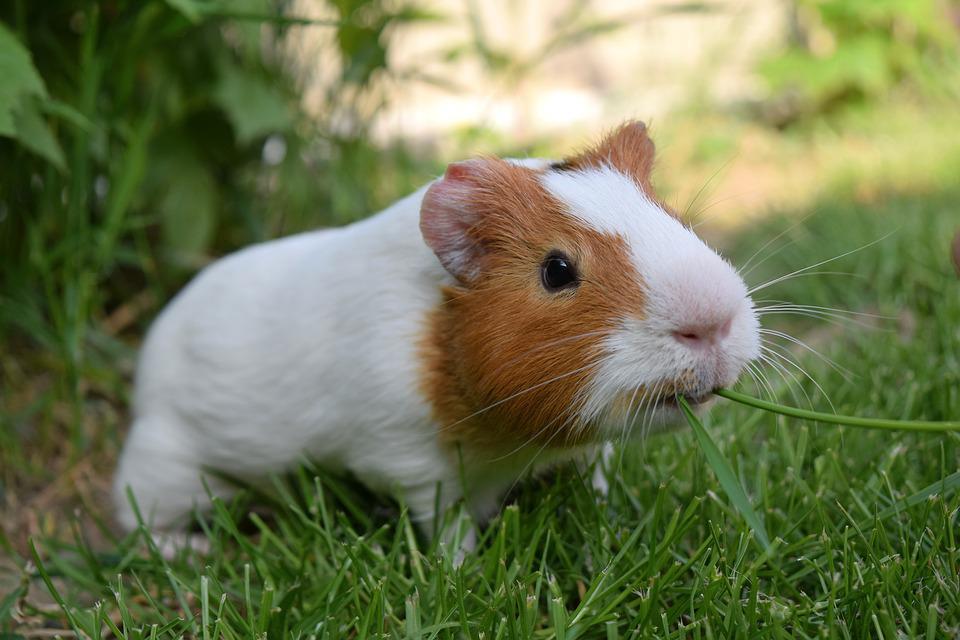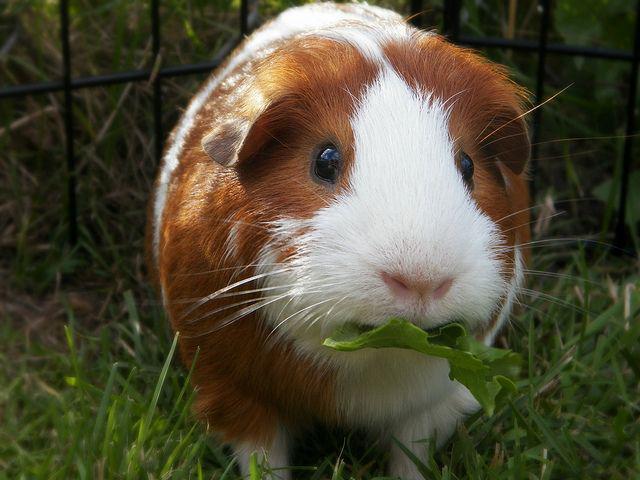The first image is the image on the left, the second image is the image on the right. For the images shown, is this caption "One of the animals is brown." true? Answer yes or no. No. 